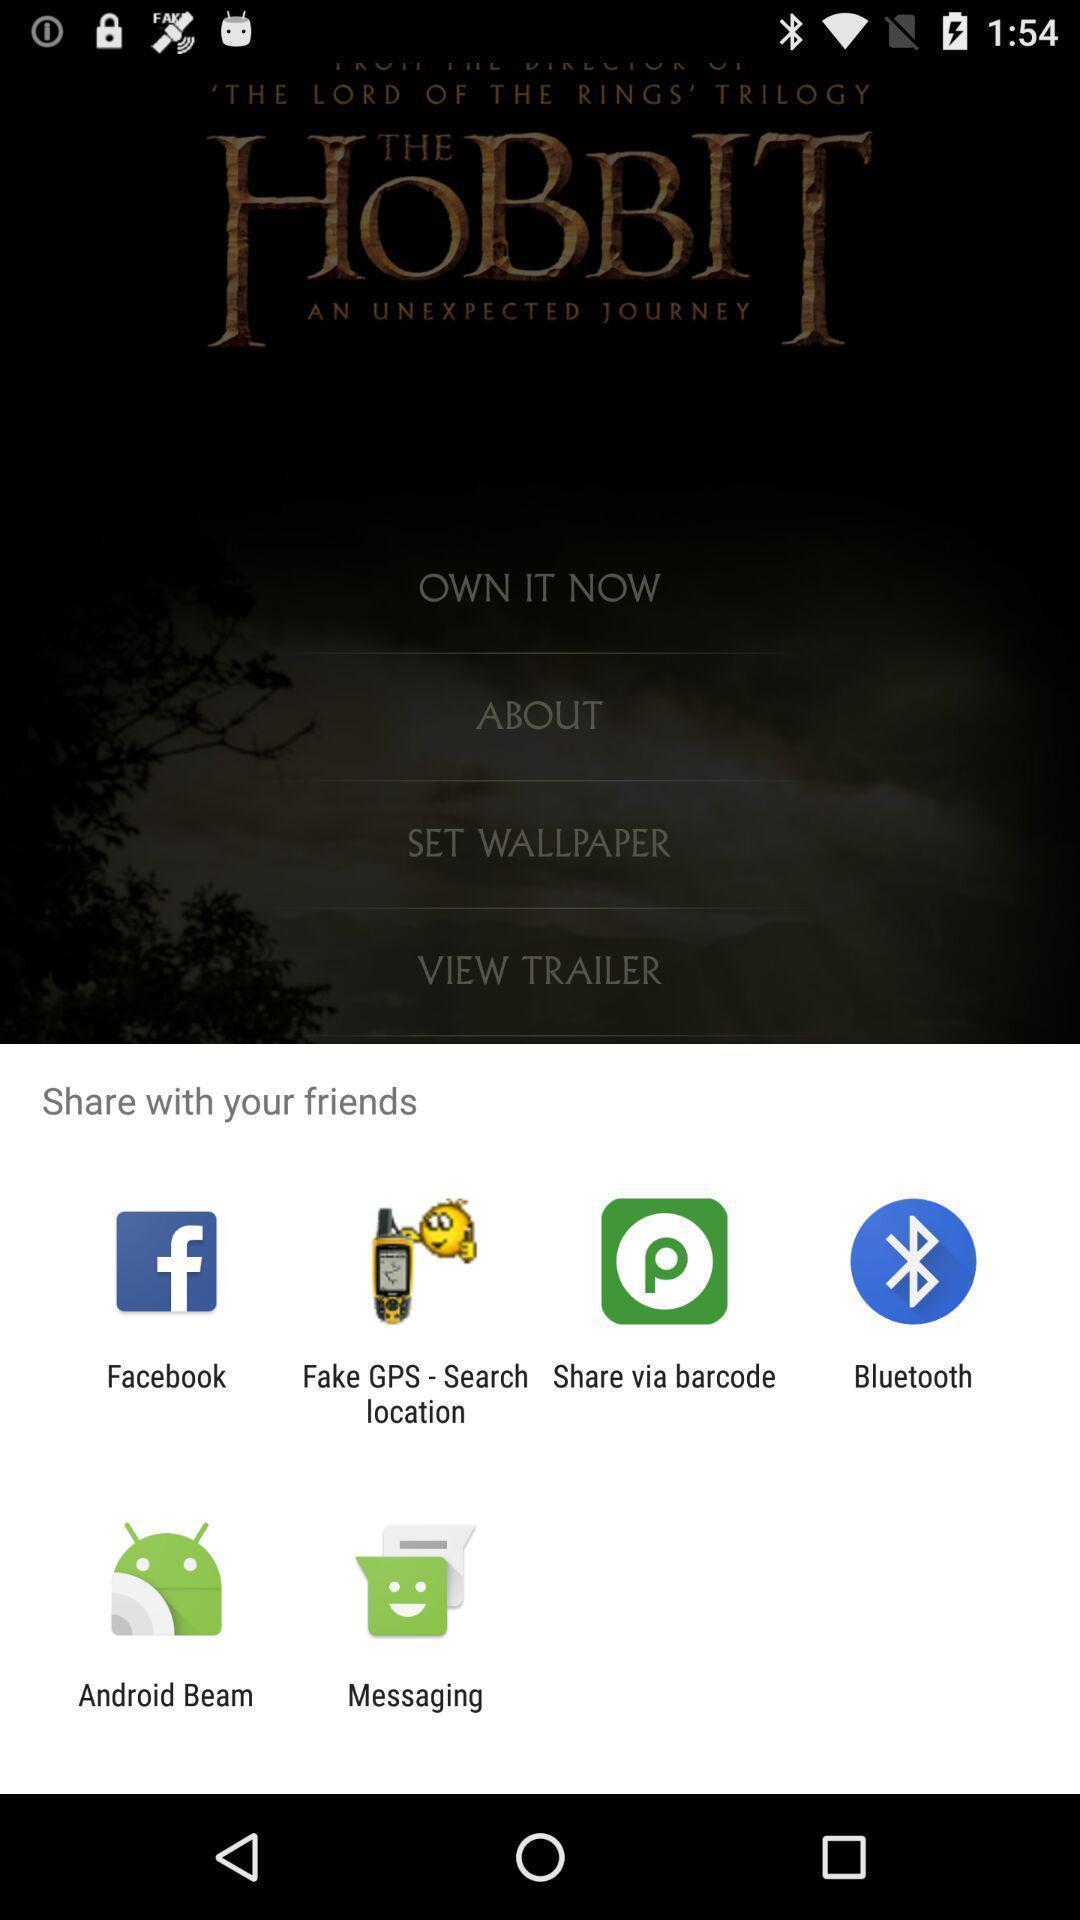Describe the content in this image. Pop-up shows to share with your friends multiple applications. 